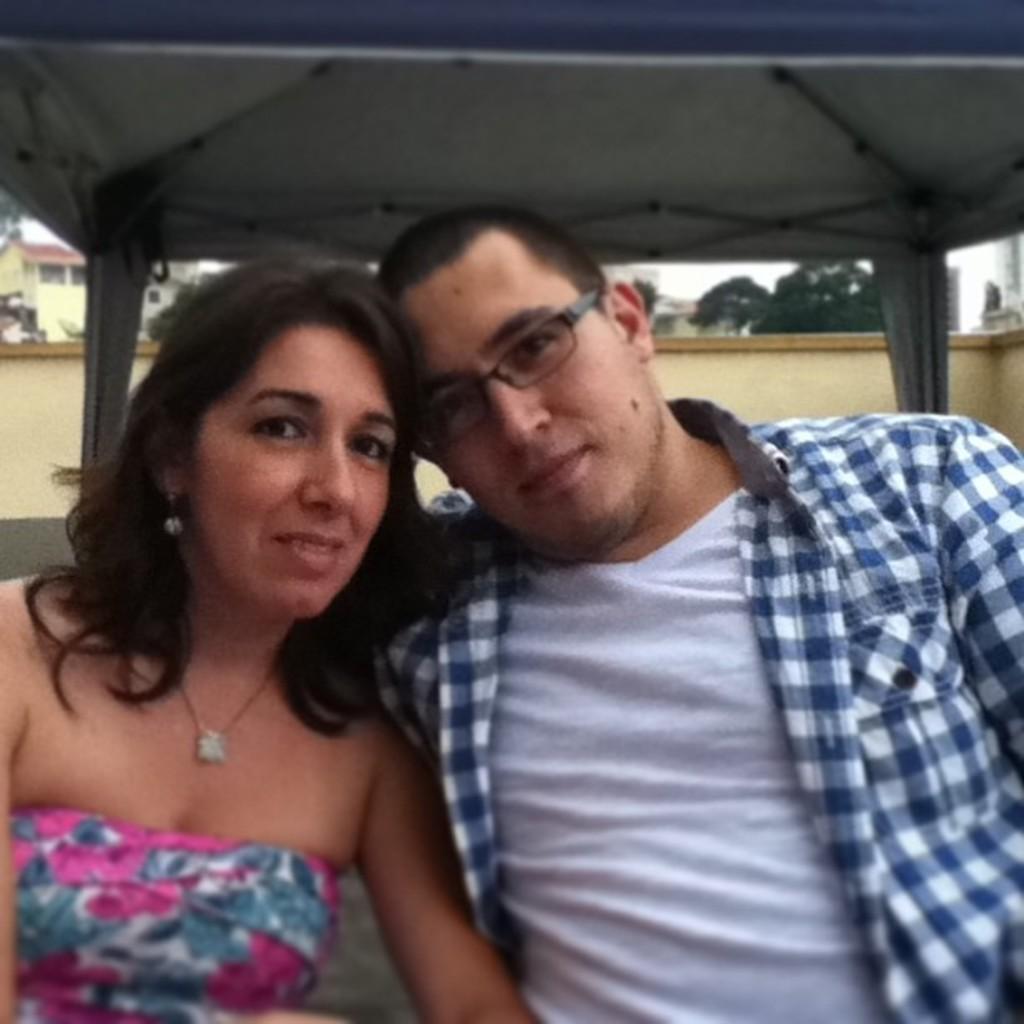Can you describe this image briefly? In this image in the front there are persons sitting. In the background there is a wall and there are trees, there are houses and the woman sitting in the front on the left side is smiling. 